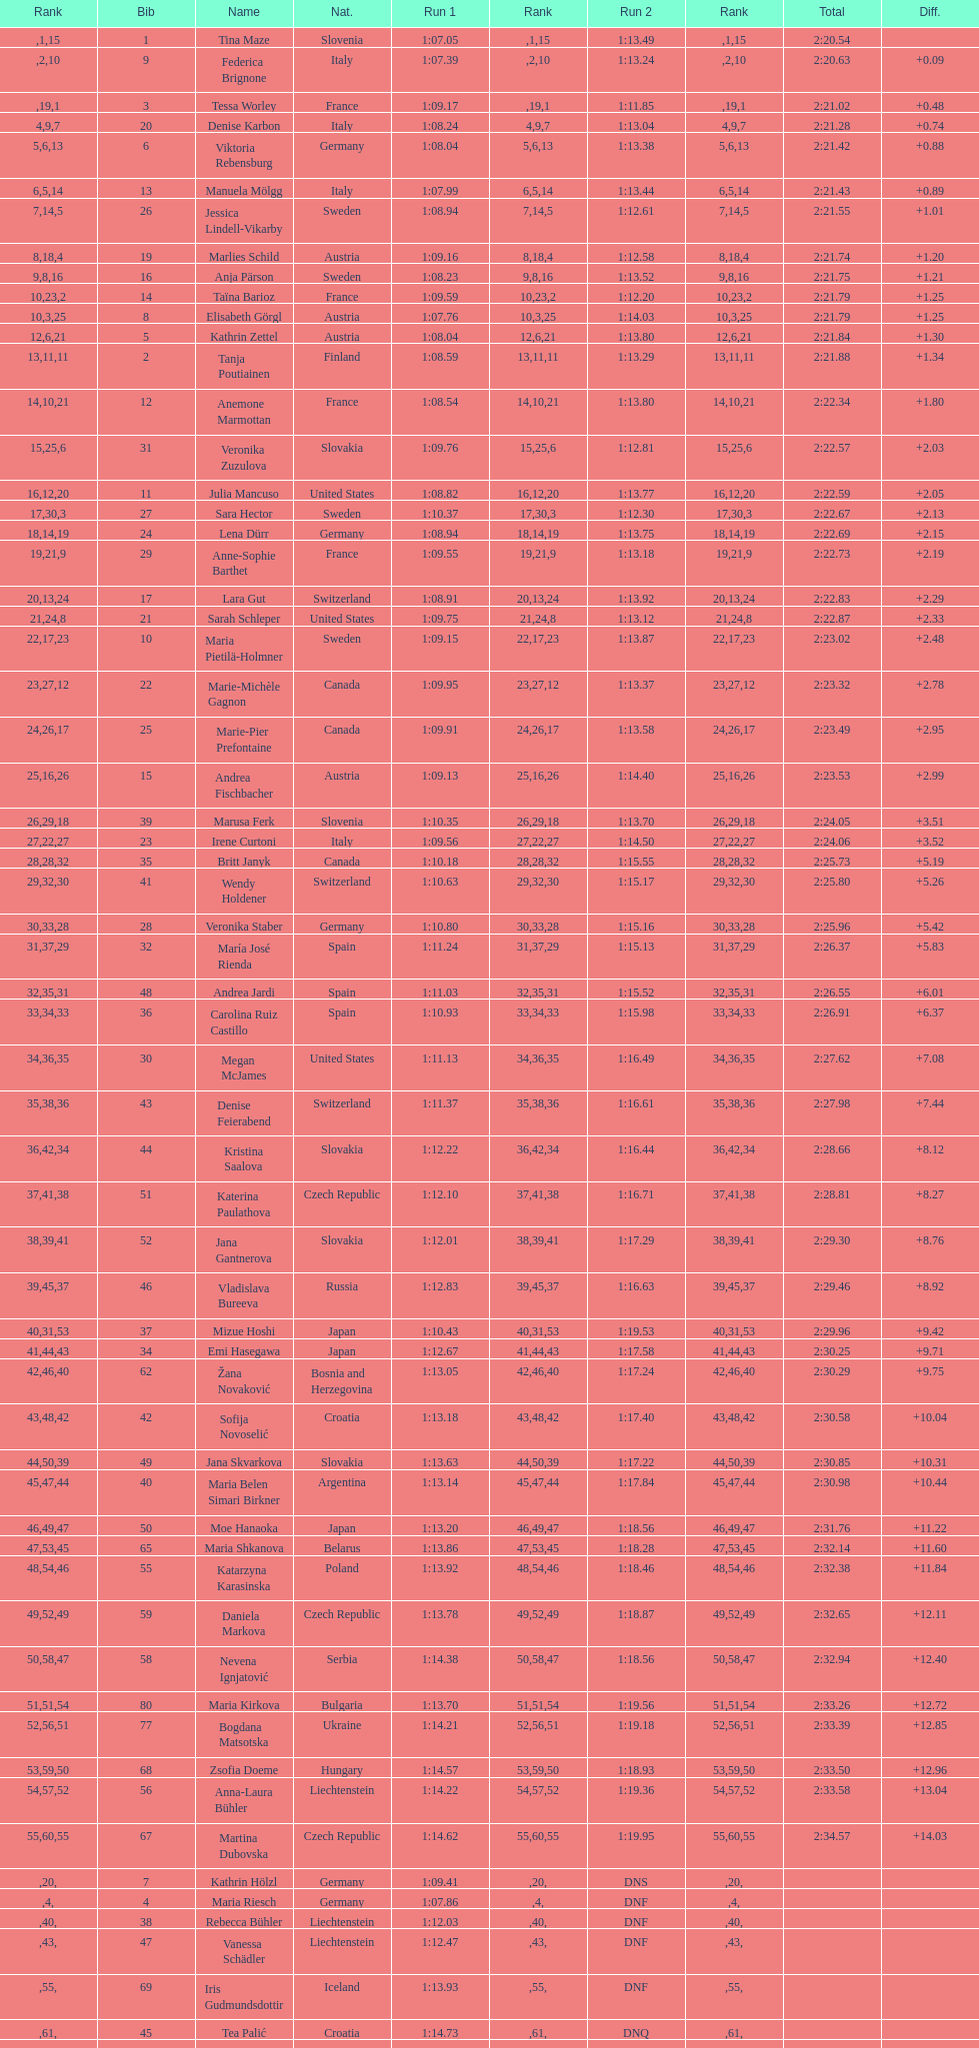In what length of time did tina maze finish the race? 2:20.54. 